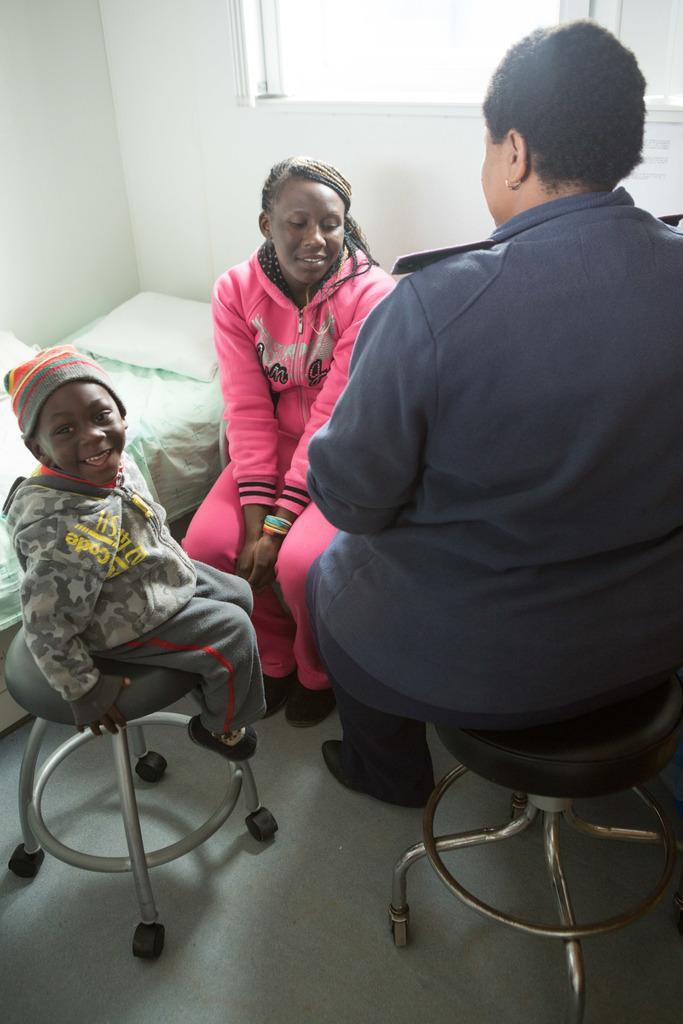Describe this image in one or two sentences. In this image I can see 3 people among them, a woman and a child sitting on a stool and a woman is sitting on a chair. Beside this woman we have a bed and a white wall. 